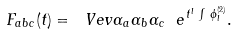<formula> <loc_0><loc_0><loc_500><loc_500>F _ { a b c } ( t ) = \ V e v { \alpha _ { a } \alpha _ { b } \alpha _ { c } \ e ^ { \, t ^ { l } \, \int \, \phi _ { l } ^ { ( 2 ) } } } .</formula> 